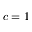Convert formula to latex. <formula><loc_0><loc_0><loc_500><loc_500>c = 1</formula> 